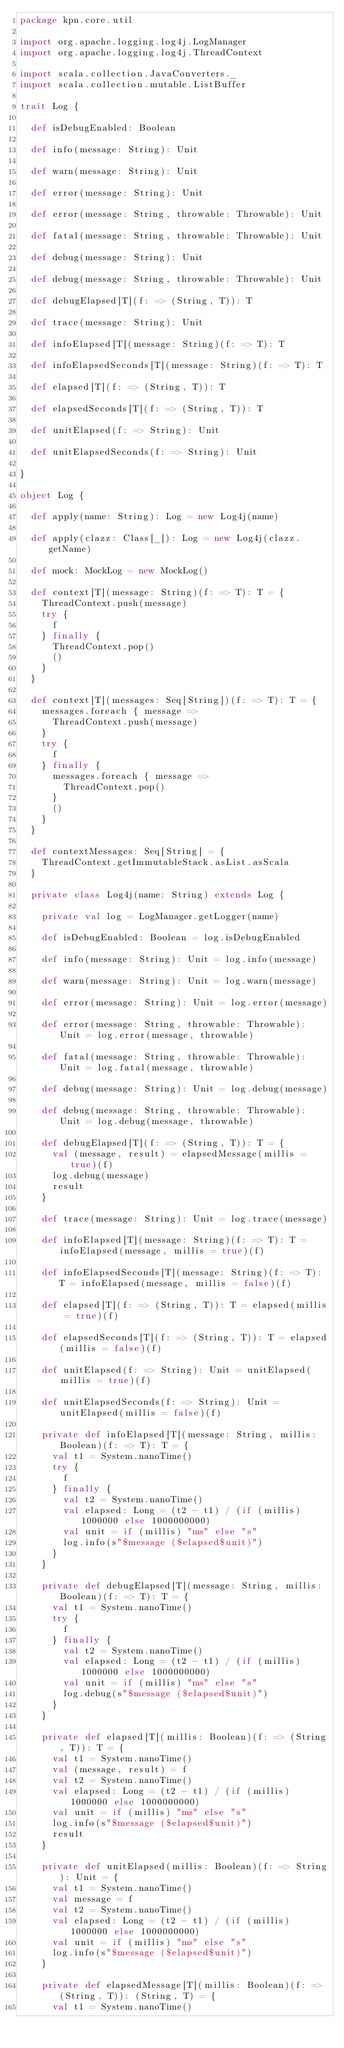Convert code to text. <code><loc_0><loc_0><loc_500><loc_500><_Scala_>package kpn.core.util

import org.apache.logging.log4j.LogManager
import org.apache.logging.log4j.ThreadContext

import scala.collection.JavaConverters._
import scala.collection.mutable.ListBuffer

trait Log {

  def isDebugEnabled: Boolean

  def info(message: String): Unit

  def warn(message: String): Unit

  def error(message: String): Unit

  def error(message: String, throwable: Throwable): Unit

  def fatal(message: String, throwable: Throwable): Unit

  def debug(message: String): Unit

  def debug(message: String, throwable: Throwable): Unit

  def debugElapsed[T](f: => (String, T)): T

  def trace(message: String): Unit

  def infoElapsed[T](message: String)(f: => T): T

  def infoElapsedSeconds[T](message: String)(f: => T): T

  def elapsed[T](f: => (String, T)): T

  def elapsedSeconds[T](f: => (String, T)): T

  def unitElapsed(f: => String): Unit

  def unitElapsedSeconds(f: => String): Unit

}

object Log {

  def apply(name: String): Log = new Log4j(name)

  def apply(clazz: Class[_]): Log = new Log4j(clazz.getName)

  def mock: MockLog = new MockLog()

  def context[T](message: String)(f: => T): T = {
    ThreadContext.push(message)
    try {
      f
    } finally {
      ThreadContext.pop()
      ()
    }
  }

  def context[T](messages: Seq[String])(f: => T): T = {
    messages.foreach { message =>
      ThreadContext.push(message)
    }
    try {
      f
    } finally {
      messages.foreach { message =>
        ThreadContext.pop()
      }
      ()
    }
  }

  def contextMessages: Seq[String] = {
    ThreadContext.getImmutableStack.asList.asScala
  }

  private class Log4j(name: String) extends Log {

    private val log = LogManager.getLogger(name)

    def isDebugEnabled: Boolean = log.isDebugEnabled

    def info(message: String): Unit = log.info(message)

    def warn(message: String): Unit = log.warn(message)

    def error(message: String): Unit = log.error(message)

    def error(message: String, throwable: Throwable): Unit = log.error(message, throwable)

    def fatal(message: String, throwable: Throwable): Unit = log.fatal(message, throwable)

    def debug(message: String): Unit = log.debug(message)

    def debug(message: String, throwable: Throwable): Unit = log.debug(message, throwable)

    def debugElapsed[T](f: => (String, T)): T = {
      val (message, result) = elapsedMessage(millis = true)(f)
      log.debug(message)
      result
    }

    def trace(message: String): Unit = log.trace(message)

    def infoElapsed[T](message: String)(f: => T): T = infoElapsed(message, millis = true)(f)

    def infoElapsedSeconds[T](message: String)(f: => T): T = infoElapsed(message, millis = false)(f)

    def elapsed[T](f: => (String, T)): T = elapsed(millis = true)(f)

    def elapsedSeconds[T](f: => (String, T)): T = elapsed(millis = false)(f)

    def unitElapsed(f: => String): Unit = unitElapsed(millis = true)(f)

    def unitElapsedSeconds(f: => String): Unit = unitElapsed(millis = false)(f)

    private def infoElapsed[T](message: String, millis: Boolean)(f: => T): T = {
      val t1 = System.nanoTime()
      try {
        f
      } finally {
        val t2 = System.nanoTime()
        val elapsed: Long = (t2 - t1) / (if (millis) 1000000 else 1000000000)
        val unit = if (millis) "ms" else "s"
        log.info(s"$message ($elapsed$unit)")
      }
    }

    private def debugElapsed[T](message: String, millis: Boolean)(f: => T): T = {
      val t1 = System.nanoTime()
      try {
        f
      } finally {
        val t2 = System.nanoTime()
        val elapsed: Long = (t2 - t1) / (if (millis) 1000000 else 1000000000)
        val unit = if (millis) "ms" else "s"
        log.debug(s"$message ($elapsed$unit)")
      }
    }

    private def elapsed[T](millis: Boolean)(f: => (String, T)): T = {
      val t1 = System.nanoTime()
      val (message, result) = f
      val t2 = System.nanoTime()
      val elapsed: Long = (t2 - t1) / (if (millis) 1000000 else 1000000000)
      val unit = if (millis) "ms" else "s"
      log.info(s"$message ($elapsed$unit)")
      result
    }

    private def unitElapsed(millis: Boolean)(f: => String): Unit = {
      val t1 = System.nanoTime()
      val message = f
      val t2 = System.nanoTime()
      val elapsed: Long = (t2 - t1) / (if (millis) 1000000 else 1000000000)
      val unit = if (millis) "ms" else "s"
      log.info(s"$message ($elapsed$unit)")
    }

    private def elapsedMessage[T](millis: Boolean)(f: => (String, T)): (String, T) = {
      val t1 = System.nanoTime()</code> 